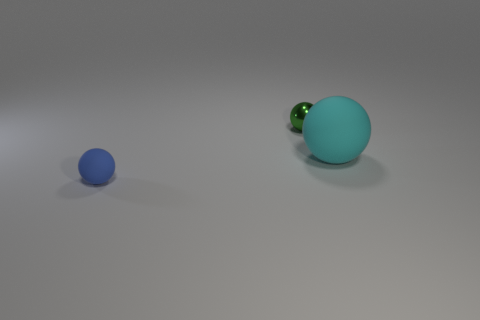Do the shadows tell us anything about the lighting in the scene? Yes, the shadows cast by the balls suggest that there is a single light source coming from the upper left side of the image, creating soft edged shadows to the right of each ball. 